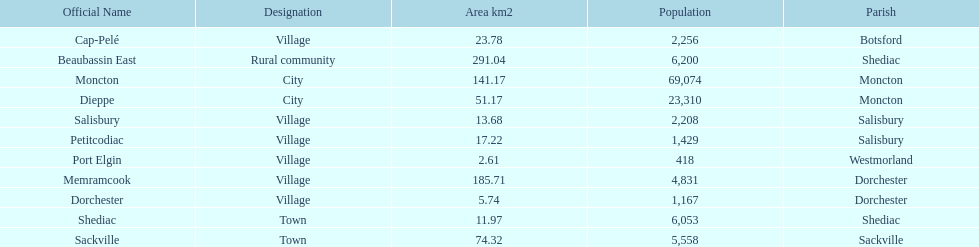How many municipalities have areas that are below 50 square kilometers? 6. 